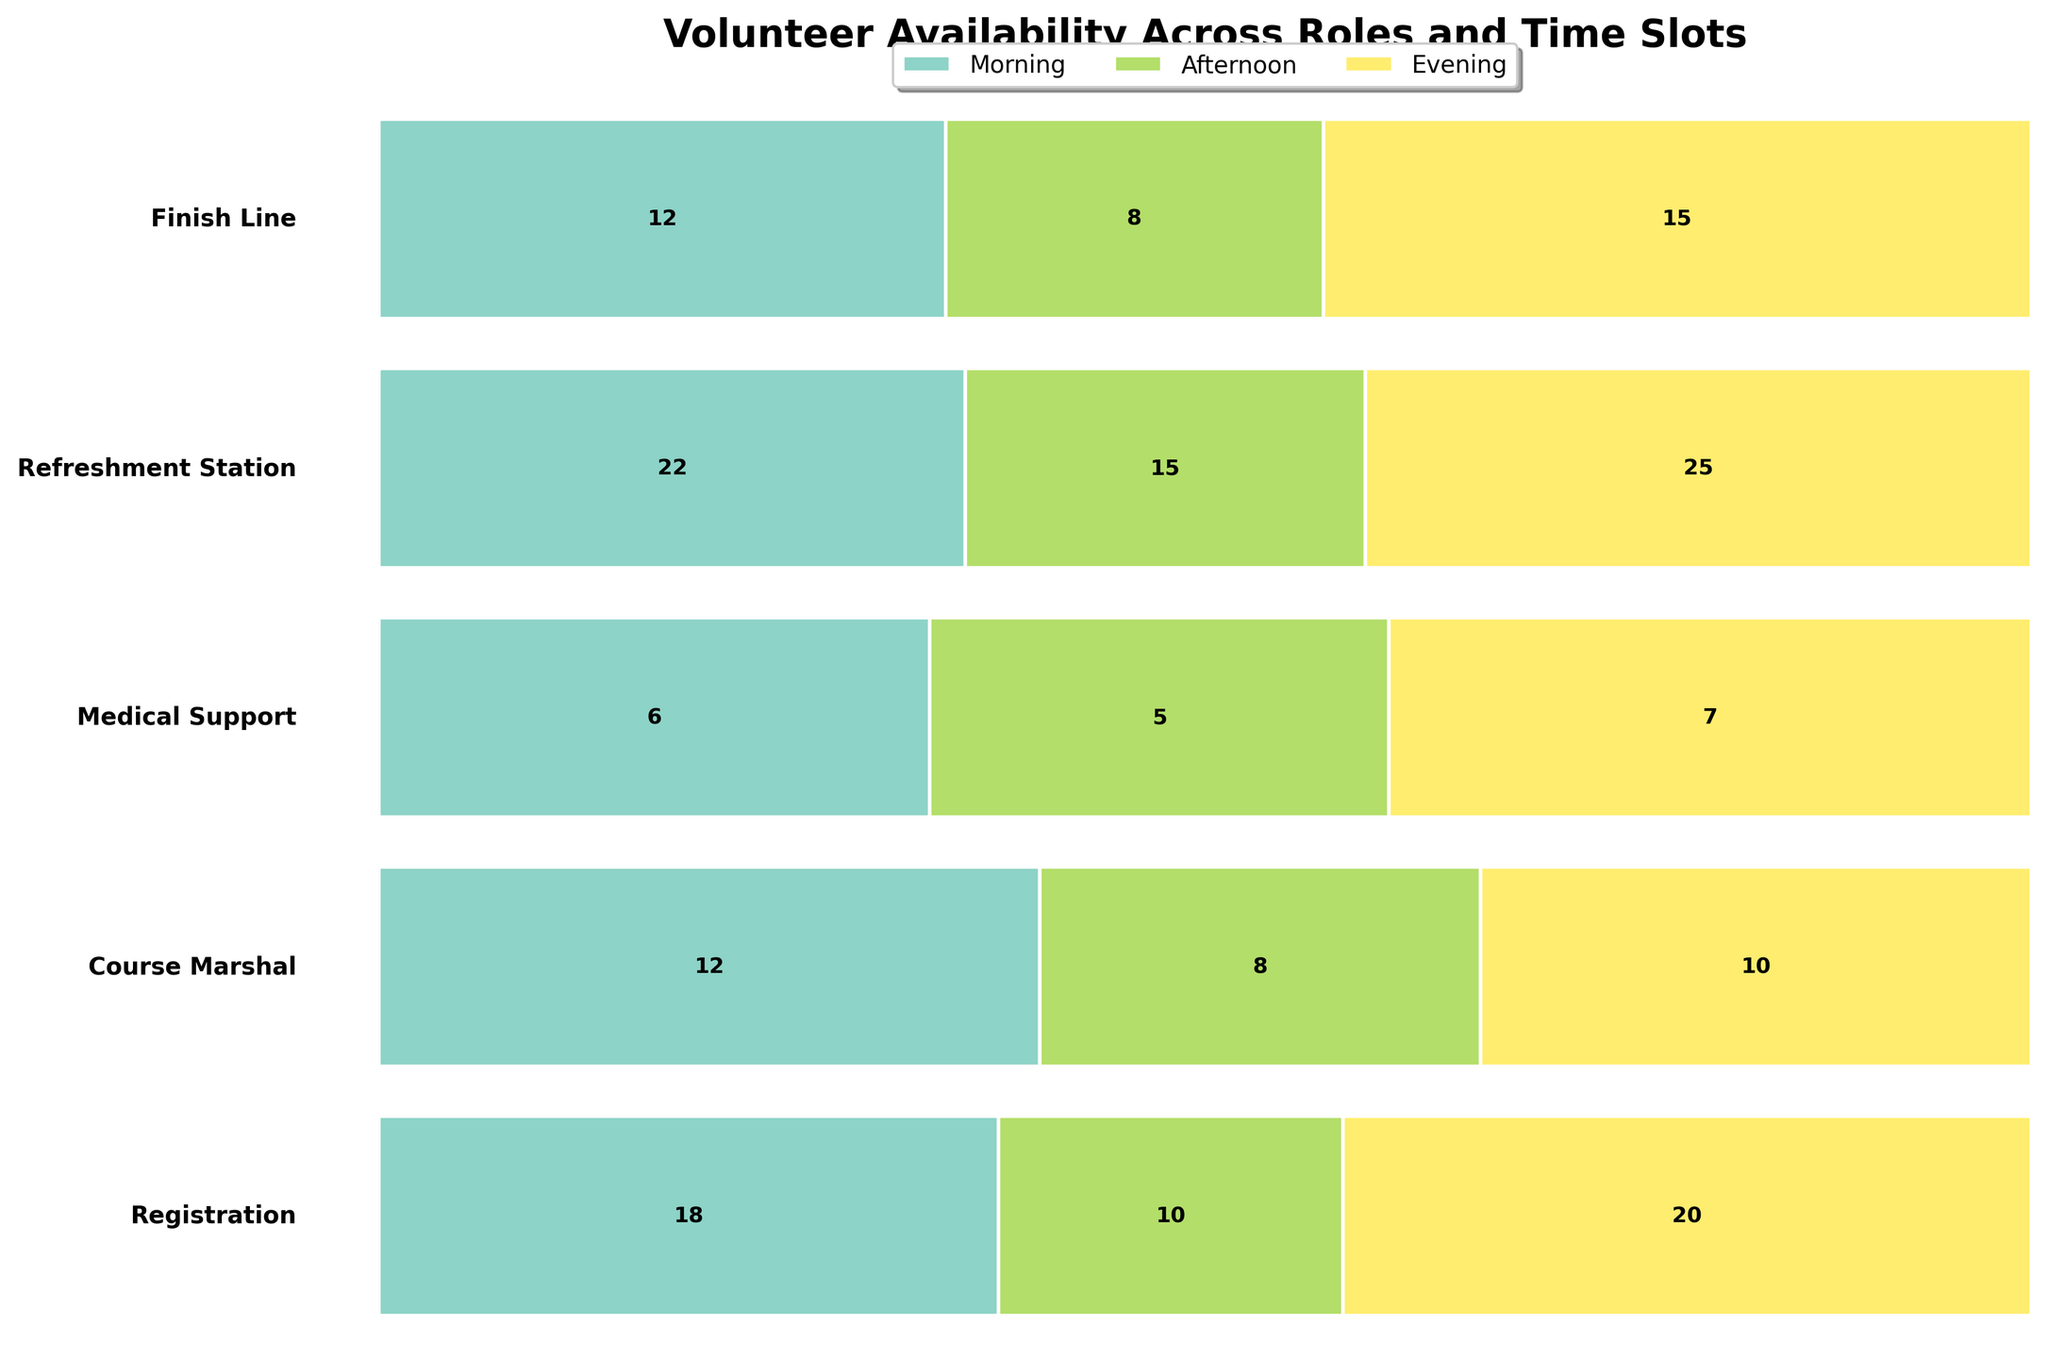What's the title of the figure? The title of the figure usually appears at the top of the chart and gives a summary of what the chart represents. In this case, it should describe the overall data related to Volunteer Availability across roles and time slots.
Answer: Volunteer Availability Across Roles and Time Slots Which time slot has the most volunteers for the Registration role? To determine the time slot with the most volunteers for the Registration role, look for the largest segment within the row labeled "Registration." The morning slot has the highest value.
Answer: Morning What is the exact number of volunteers available for Medical Support in the evening? Find the Medical Support role on the y-axis and look at the segment labeled "Evening." The number inside this segment will be the available volunteers.
Answer: 5 How many total volunteers are available for Course Marshal across all time slots? To find the total, add the volunteer numbers for Course Marshal across Morning, Afternoon, and Evening. 20 (Morning) + 18 (Afternoon) + 10 (Evening) = 48.
Answer: 48 Which role has the least number of volunteers available in the afternoon? Compare the Afternoon segments for all roles and look for the smallest value. Medical Support, with 6 volunteers, has the least.
Answer: Medical Support What is the combined total of volunteers available for Finish Line and Registration in the evening time slot? Add the volunteers available for Finish Line (8) and Registration (8) in the evening time slot. 8 + 8 = 16.
Answer: 16 Which time slot has the highest overall number of volunteers across all roles? Sum the number of volunteers available in each time slot for all roles and compare the totals. Morning: 15+20+7+25+10, Afternoon: 12+18+6+22+12, Evening: 8+10+5+15+8. The Morning slot has the highest total.
Answer: Morning Is the distribution of volunteers more balanced across time slots for Medical Support or for Refreshment Station? Compare the size uniformity of the segments across Morning, Afternoon, and Evening for both roles. Refreshment Station has more balanced distribution as the segments' sizes are closer to each other.
Answer: Refreshment Station About how much larger is the number of volunteers for Refreshment Station in the morning compared to the Medical Support in the same time slot? Compare the Morning segments for both roles. Refreshment Station has 25 volunteers and Medical Support has 7. The difference: 25 - 7 = 18.
Answer: 18 What's the ratio of volunteers in the Morning slot for Registration role to those in the Afternoon slot for the same role? Find the numbers for both Morning (15) and Afternoon (12) slots for Registration and compute the ratio. 15 / 12 = 1.25.
Answer: 1.25 